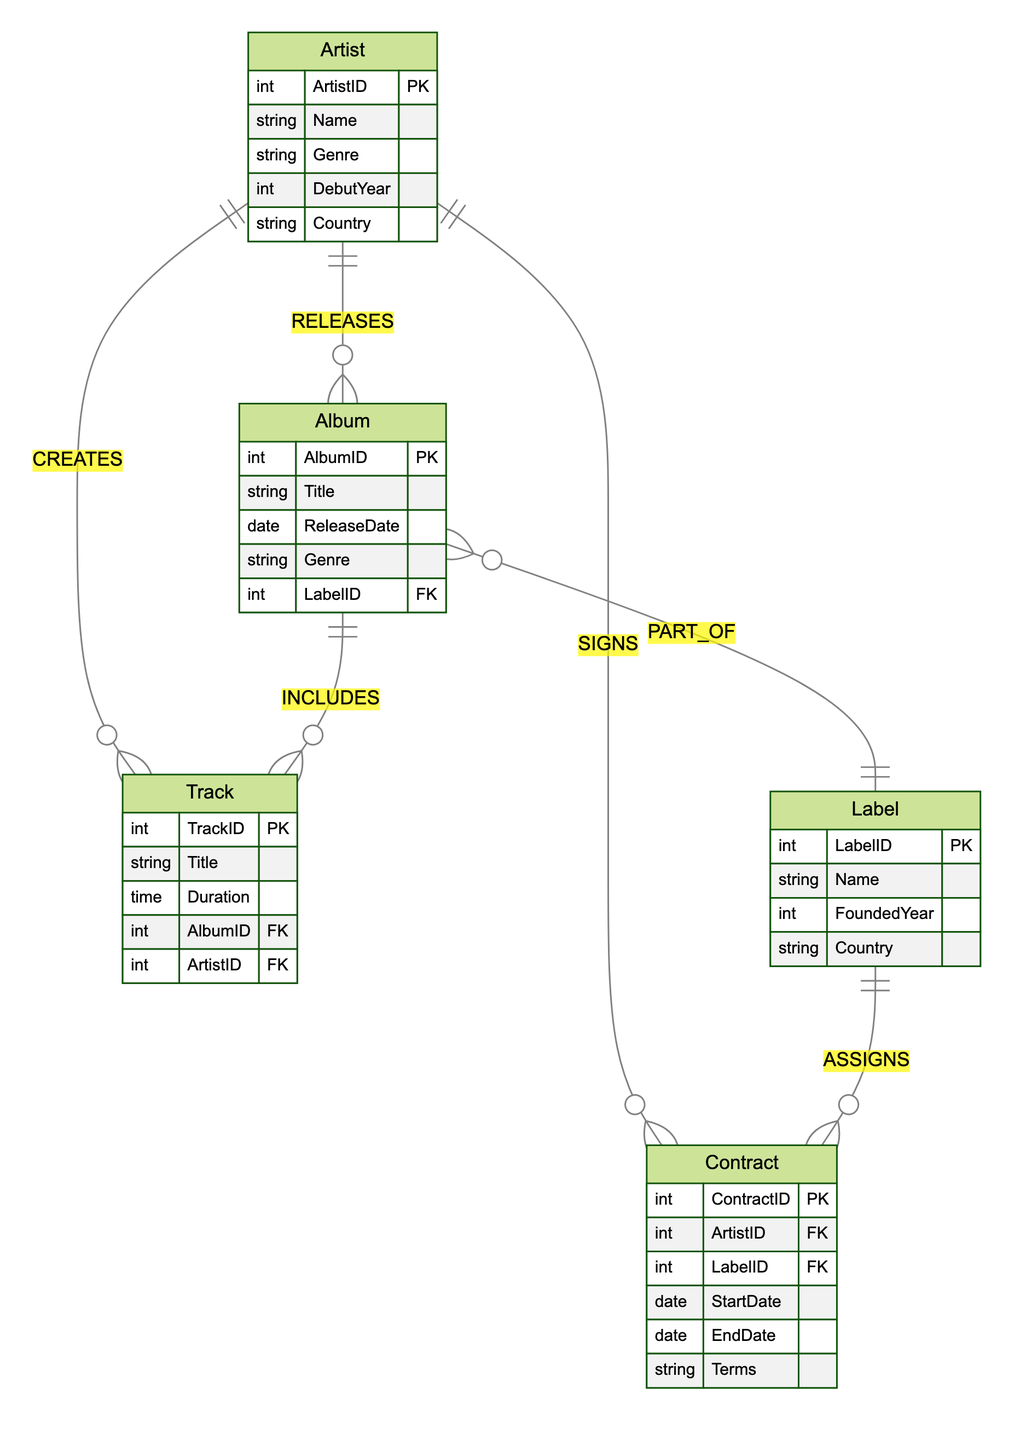What is the primary key of the Artist entity? The primary key of the Artist entity is ArtistID, which uniquely identifies each artist in the database.
Answer: ArtistID How many relationships involve the Album entity? By analyzing the diagram, Album is involved in three relationships: RELEASES (with Artist), PART_OF (with Label), and INCLUDES (with Track).
Answer: Three What does the 'SIGNS' relationship represent? The SIGNS relationship indicates that one artist can have multiple contracts, thus depicting a one-to-many relationship between the Artist and Contract entities.
Answer: One-to-many Which entity does the Album belong to? The Album belongs to the Label entity, indicated by the PART_OF relationship, which shows that each album is associated with one specific record label.
Answer: Label How many attributes does the Contract entity have? The Contract entity has five attributes: ContractID, ArtistID, LabelID, StartDate, EndDate, and Terms, as listed in the diagram.
Answer: Five Which entity is responsible for creating Tracks? The Artist entity is responsible for creating Tracks, as shown by the CREATES relationship, which signifies that each artist can create multiple tracks.
Answer: Artist What type of relationship exists between Album and Track? The relationship between Album and Track is one-to-many, indicated by the INCLUDES relationship which shows that a single album can contain multiple tracks.
Answer: One-to-many What is the foreign key in the Album entity? The foreign key in the Album entity is LabelID, which establishes a relationship with the Label entity, linking each album to the record label that produces it.
Answer: LabelID How many entities are in the diagram? There are five entities in the diagram: Artist, Album, Contract, Label, and Track, as listed in the entities section.
Answer: Five 